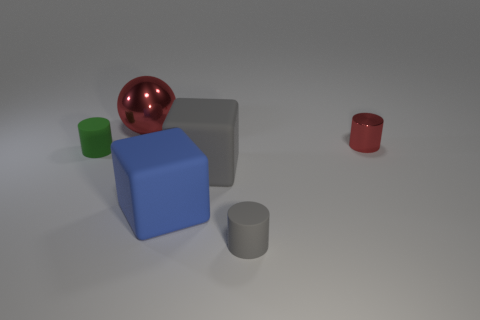There is a red object that is the same shape as the green thing; what is its size? The red object, which is a cylinder, appears to be smaller than the green cube. Based on its proportions compared to the nearby objects, the red cylinder looks to be about half the height of the blue cube and slightly narrower than the green cube. 